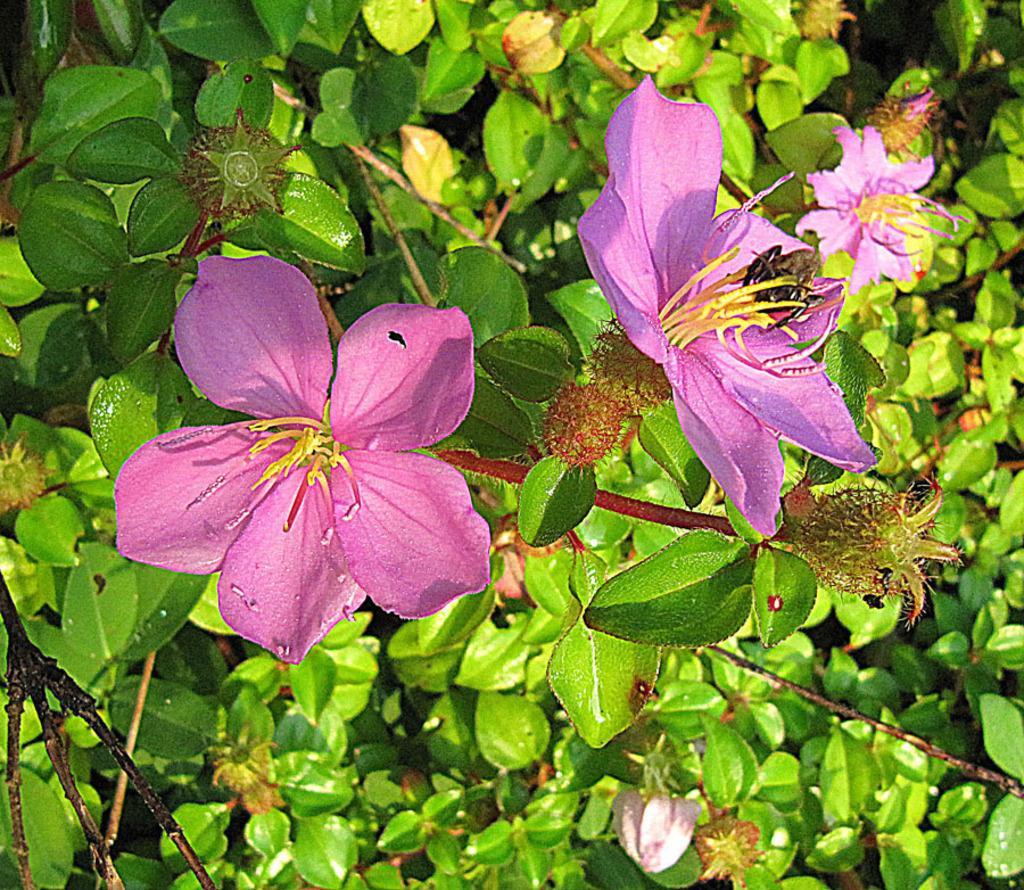How would you summarize this image in a sentence or two? Here we can see a plant with flowers. 